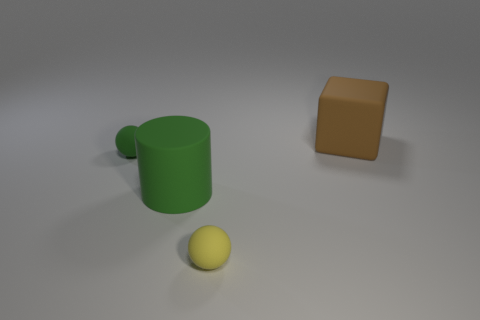Add 1 yellow metallic things. How many objects exist? 5 Subtract all cylinders. How many objects are left? 3 Add 3 things. How many things are left? 7 Add 4 big brown objects. How many big brown objects exist? 5 Subtract 0 gray cylinders. How many objects are left? 4 Subtract all small yellow rubber objects. Subtract all big rubber blocks. How many objects are left? 2 